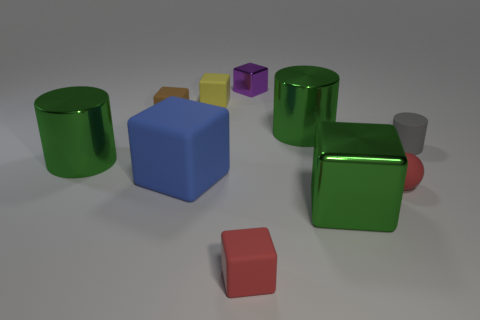Subtract 2 blocks. How many blocks are left? 4 Subtract all green blocks. How many blocks are left? 5 Subtract all shiny cubes. How many cubes are left? 4 Subtract all red cubes. Subtract all blue spheres. How many cubes are left? 5 Subtract all cubes. How many objects are left? 4 Subtract all big green metallic cubes. Subtract all red rubber blocks. How many objects are left? 8 Add 3 big blue things. How many big blue things are left? 4 Add 2 tiny blue spheres. How many tiny blue spheres exist? 2 Subtract 0 yellow cylinders. How many objects are left? 10 